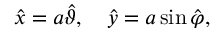Convert formula to latex. <formula><loc_0><loc_0><loc_500><loc_500>\hat { x } = a \hat { \vartheta } , \quad \hat { y } = a \sin \hat { \varphi } ,</formula> 